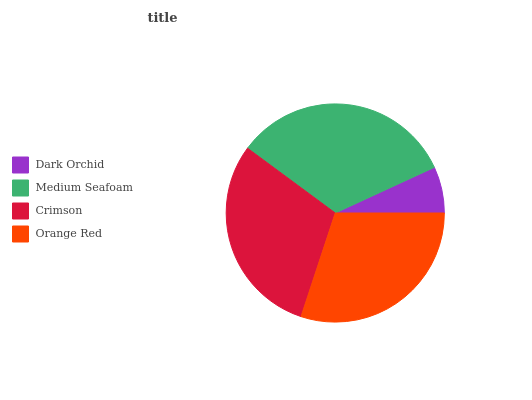Is Dark Orchid the minimum?
Answer yes or no. Yes. Is Medium Seafoam the maximum?
Answer yes or no. Yes. Is Crimson the minimum?
Answer yes or no. No. Is Crimson the maximum?
Answer yes or no. No. Is Medium Seafoam greater than Crimson?
Answer yes or no. Yes. Is Crimson less than Medium Seafoam?
Answer yes or no. Yes. Is Crimson greater than Medium Seafoam?
Answer yes or no. No. Is Medium Seafoam less than Crimson?
Answer yes or no. No. Is Orange Red the high median?
Answer yes or no. Yes. Is Crimson the low median?
Answer yes or no. Yes. Is Dark Orchid the high median?
Answer yes or no. No. Is Medium Seafoam the low median?
Answer yes or no. No. 